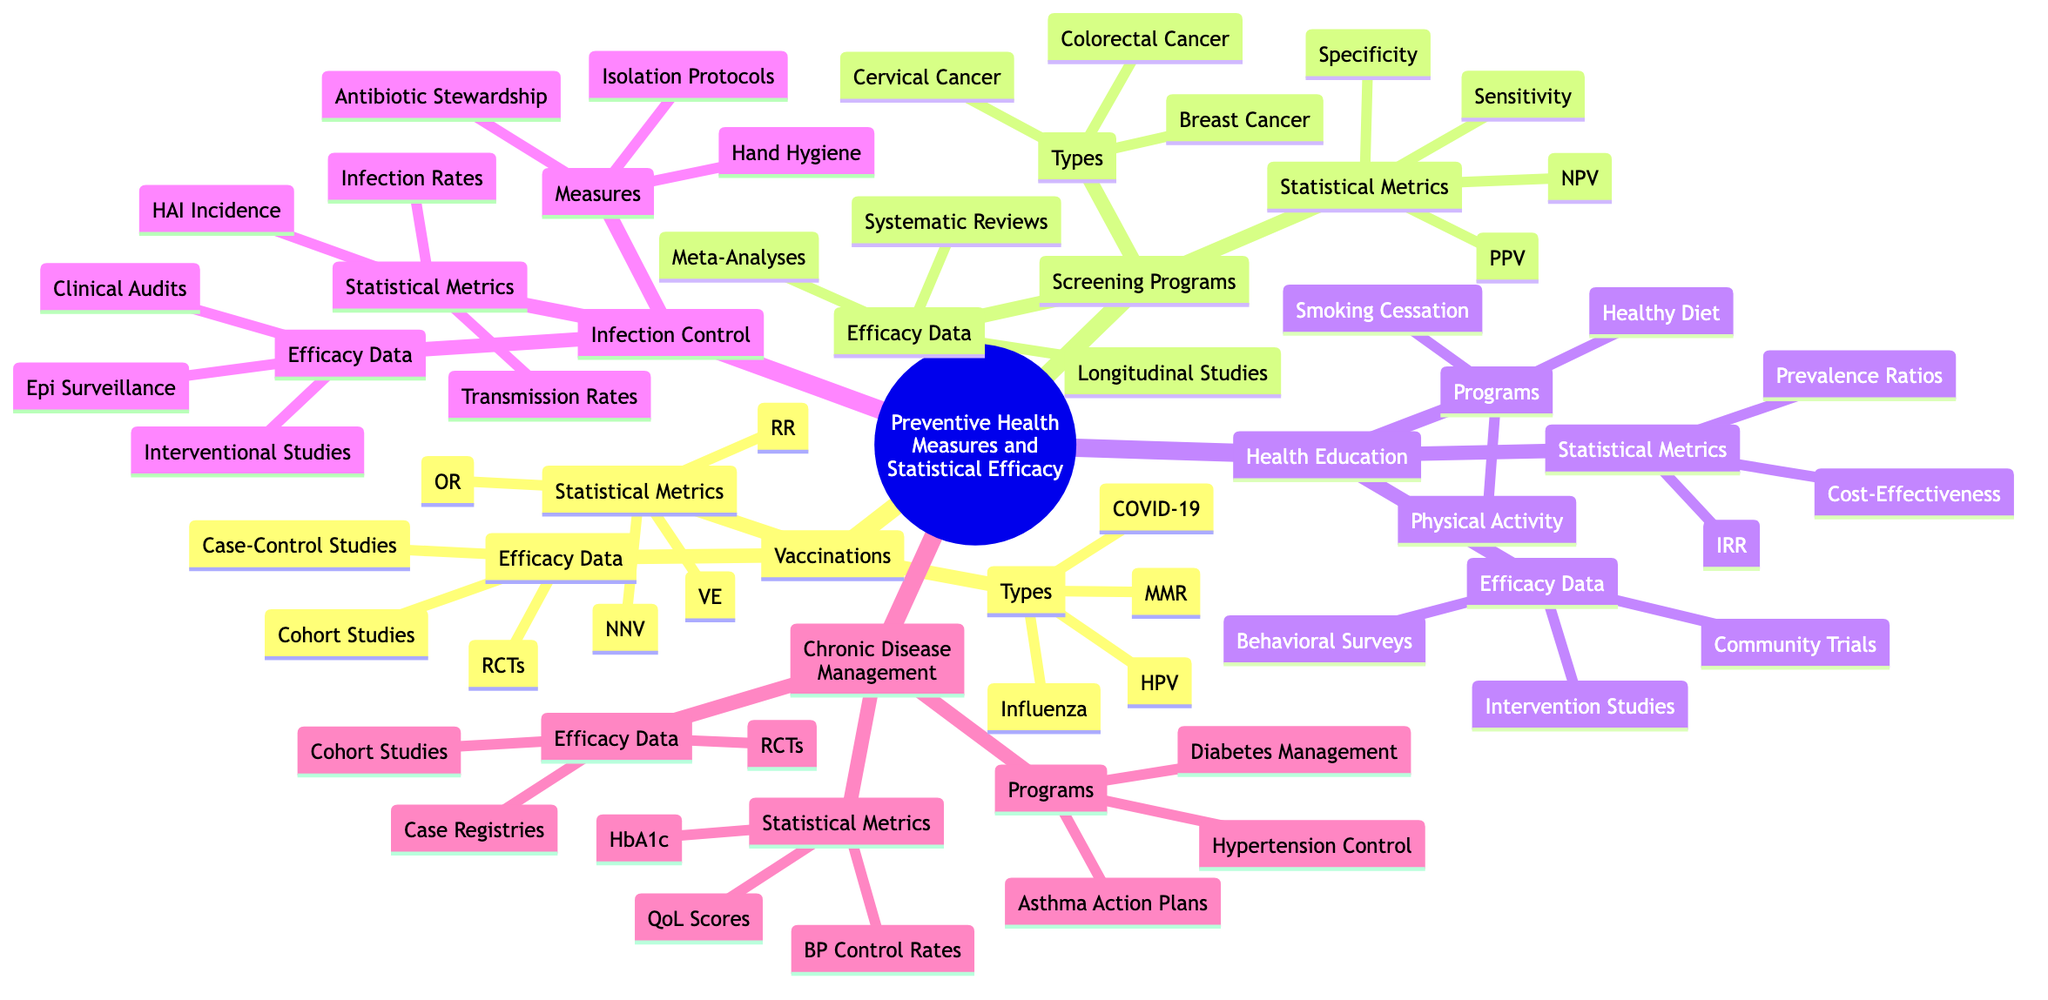What are the types of vaccines listed? The diagram indicates that there are four types of vaccines: Influenza, Measles-Mumps-Rubella (MMR), Human Papillomavirus (HPV), and COVID-19, which are specifically categorized under the 'Vaccinations' section.
Answer: Influenza, MMR, HPV, COVID-19 How many programs are under Health Education? In the 'Health Education' section, three programs are listed: Smoking Cessation Campaigns, Healthy Diet Workshops, and Physical Activity Promotion. Therefore, the count of programs is derived directly from the nodes under 'Programs'.
Answer: 3 What type of study is used for Vaccination Efficacy data? The 'Efficacy Data' under the 'Vaccinations' category includes Randomized Controlled Trials, Cohort Studies, and Case-Control Studies. Any of these can be used for assessing vaccination efficacy, showing the different methodologies employed.
Answer: Randomized Controlled Trials What is the statistical metric associated with Chronic Disease Management? Under the 'Chronic Disease Management' category, several statistical metrics are identified, including Glycemic Control Metrics (HbA1c), Blood Pressure Control Rates, and Quality of Life Scores. Thus, one metric's relation can be taken to examine effectiveness.
Answer: Glycemic Control Metrics (HbA1c) Which screening program type has the most nodes? The 'Screening Programs' section shows three different types: Breast Cancer Screening (Mammography), Cervical Cancer Screening (Pap Smear), and Colorectal Cancer Screening (Colonoscopy). Each has the same numerical representation, indicating equal categorization.
Answer: 3 What is the efficacy data type for Infection Control? The structure of the 'Infection Control' section lists three types of efficacy data: Interventional Studies, Epidemiological Surveillance, and Clinical Audits, which are directly tied to evaluating interventions in infection control measures.
Answer: Interventional Studies What is one program found under Chronic Disease Management? In the 'Chronic Disease Management' section, three programs are provided: Diabetes Management Programs, Hypertension Control Strategies, and Asthma Action Plans. Any program can be selected to represent this area.
Answer: Diabetes Management Programs Which statistical metric is found under Screening Programs? Within the 'Screening Programs' category, four statistical metrics are outlined, including Sensitivity, Specificity, Positive Predictive Value, and Negative Predictive Value, used for evaluating screening tests' effectiveness.
Answer: Sensitivity What measure is included in Infection Control? The 'Infection Control' section lists several measures, such as Hand Hygiene, Antibiotic Stewardship, and Isolation Protocols. One of these measures can effectively summarize the prevention strategies outlined.
Answer: Hand Hygiene 